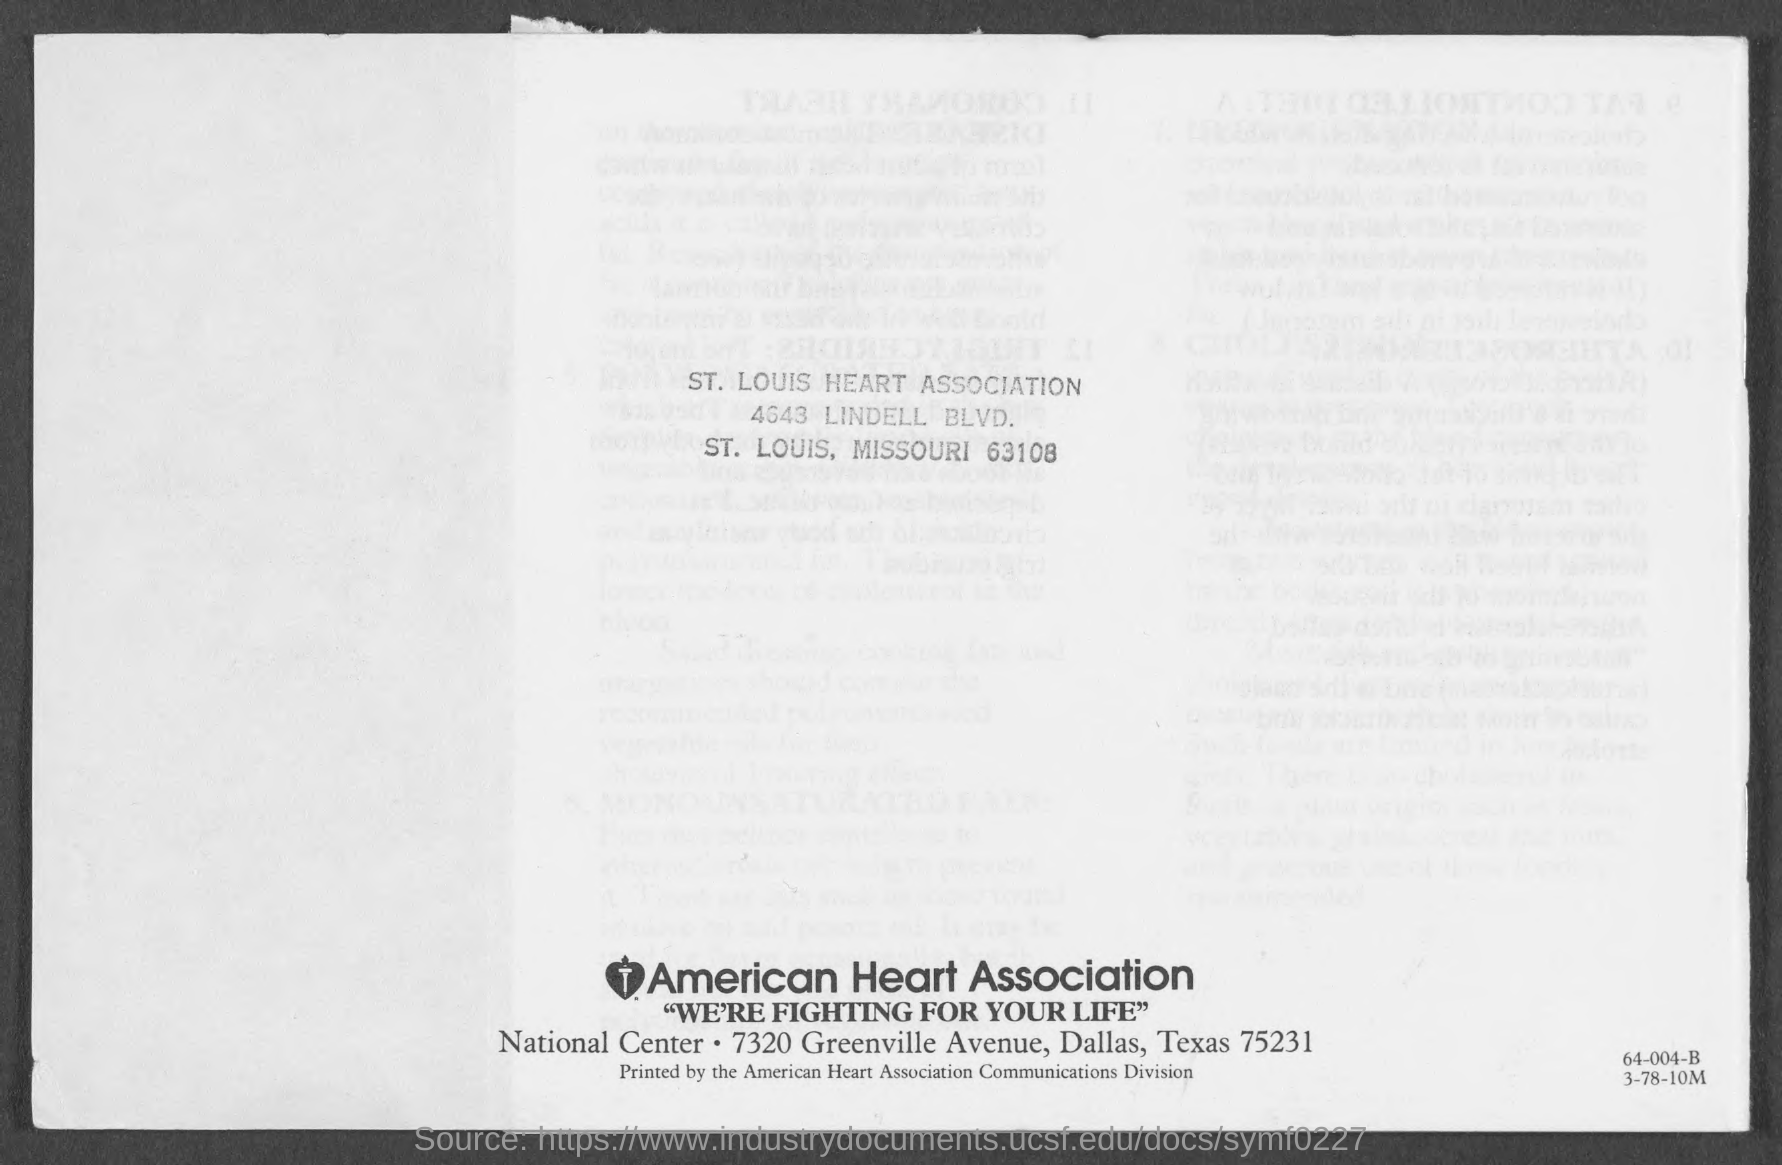In which city is the st. louis heart association?
Offer a terse response. St. Louis. In which state is the american heart association?
Keep it short and to the point. Texas. What is the slogan of american heart association?
Ensure brevity in your answer.  We're fighting for your life. 